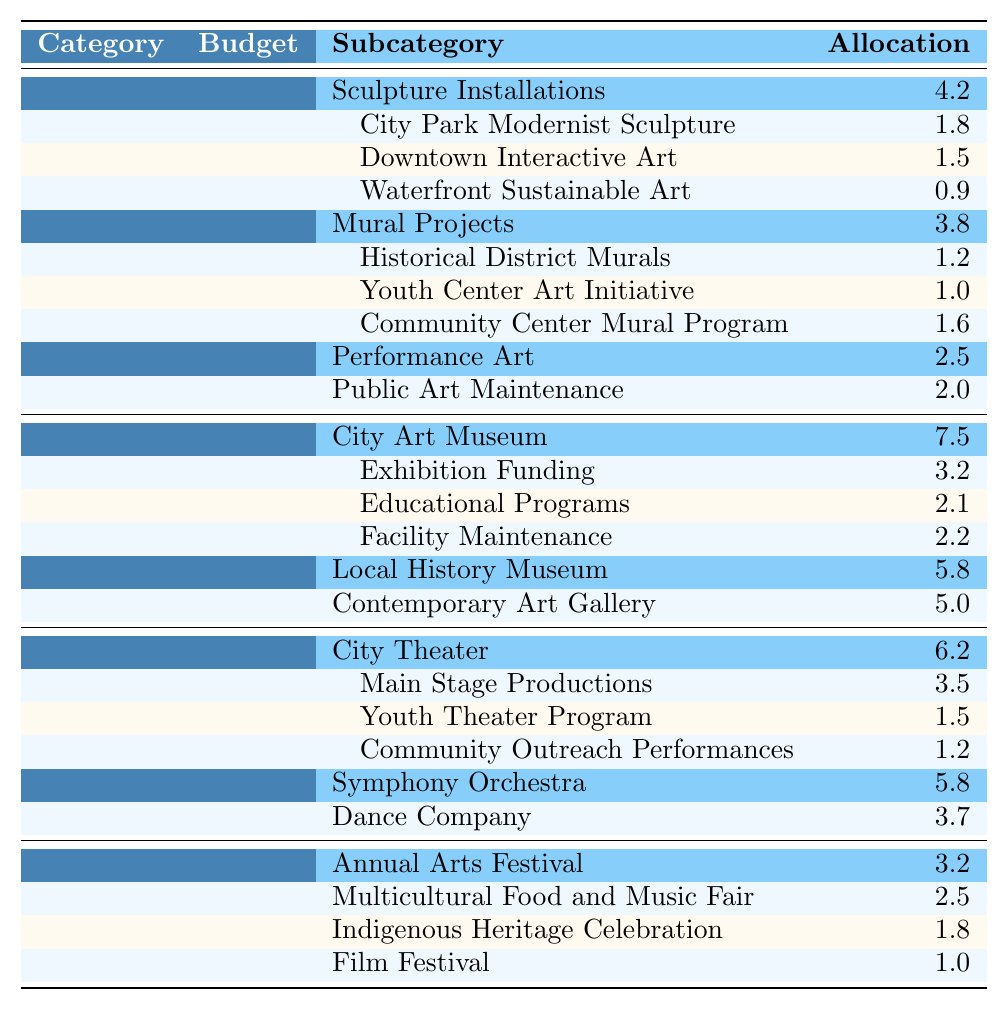What is the total budget allocated for Public Art Programs? The table shows a specific category for Public Art Programs with a total budget indicated. It states the amount is 12.5 million USD.
Answer: 12.5 million USD Which subcategory within Public Art Programs has the highest budget allocation? Reviewing the subcategories under Public Art Programs, Sculpture Installations, with a budget of 4.2 million USD, is the highest compared to the others.
Answer: Sculpture Installations How much funding is dedicated to Mural Projects? In the Public Art Programs section, Mural Projects is listed with a budget of 3.8 million USD.
Answer: 3.8 million USD What is the total budget for Museums and Galleries? The total budget for the Museums and Galleries category is clearly stated as 18.3 million USD.
Answer: 18.3 million USD Are there any projects under the Performance Art subcategory that received less than 1 million USD? In the Performance Art subcategory, allocations are 1.3, 0.7, and 0.5 million USD. Thus, the allocation of 0.5 million USD is less than 1 million USD.
Answer: Yes What is the combined budget of the City Theater and Dance Company? The budgets for City Theater and Dance Company are 6.2 and 3.7 million USD respectively. Summing these gives 6.2 + 3.7 = 9.9 million USD.
Answer: 9.9 million USD Which cultural festival received the least funding? From the Cultural Festivals section, Film Festival has the lowest allocated amount at 1.0 million USD, among the listed events.
Answer: Film Festival What percentage of the total budget for Cultural Initiatives does the budget for Performing Arts represent? The total budget for Cultural Initiatives is the sum of all categories: 12.5 + 18.3 + 15.7 + 8.5 = 55 million USD. The Performing Arts budget is 15.7 million USD. The percentage is (15.7 / 55) * 100 = 28.55%.
Answer: 28.55% What is the ratio of the budget for Sculpture Installations to the total budget for Public Art Programs? The budget for Sculpture Installations is 4.2 million USD and the total budget for Public Art Programs is 12.5 million USD. The ratio is 4.2 / 12.5 = 0.336 or roughly 1:3.
Answer: 1:3 Which subcategory has the same budget for projects' maintenance in Public Art Programs? The maintenance budget is allocated to Public Art Maintenance amounting to 2.0 million USD. There are no other subcategories listed for maintenance in this section, confirming that it's unique.
Answer: None 